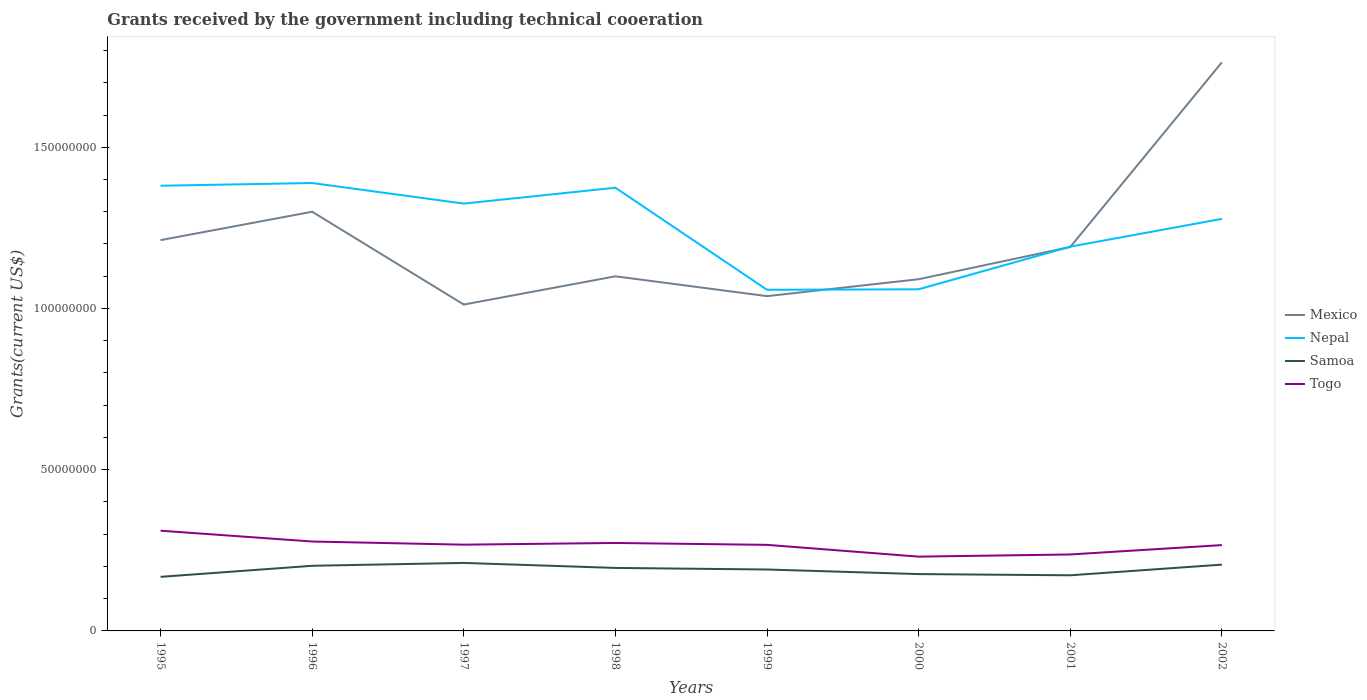How many different coloured lines are there?
Keep it short and to the point. 4. Does the line corresponding to Mexico intersect with the line corresponding to Samoa?
Keep it short and to the point. No. Across all years, what is the maximum total grants received by the government in Mexico?
Make the answer very short. 1.01e+08. In which year was the total grants received by the government in Togo maximum?
Your answer should be very brief. 2000. What is the total total grants received by the government in Togo in the graph?
Provide a succinct answer. -3.58e+06. What is the difference between the highest and the second highest total grants received by the government in Togo?
Give a very brief answer. 8.04e+06. What is the difference between the highest and the lowest total grants received by the government in Nepal?
Offer a terse response. 5. Is the total grants received by the government in Togo strictly greater than the total grants received by the government in Samoa over the years?
Keep it short and to the point. No. How many lines are there?
Keep it short and to the point. 4. How many years are there in the graph?
Offer a terse response. 8. Does the graph contain grids?
Keep it short and to the point. No. How many legend labels are there?
Offer a very short reply. 4. How are the legend labels stacked?
Ensure brevity in your answer.  Vertical. What is the title of the graph?
Provide a succinct answer. Grants received by the government including technical cooeration. Does "Japan" appear as one of the legend labels in the graph?
Your answer should be compact. No. What is the label or title of the X-axis?
Your answer should be compact. Years. What is the label or title of the Y-axis?
Give a very brief answer. Grants(current US$). What is the Grants(current US$) of Mexico in 1995?
Ensure brevity in your answer.  1.21e+08. What is the Grants(current US$) in Nepal in 1995?
Ensure brevity in your answer.  1.38e+08. What is the Grants(current US$) in Samoa in 1995?
Offer a very short reply. 1.68e+07. What is the Grants(current US$) of Togo in 1995?
Provide a short and direct response. 3.11e+07. What is the Grants(current US$) of Mexico in 1996?
Provide a succinct answer. 1.30e+08. What is the Grants(current US$) of Nepal in 1996?
Offer a terse response. 1.39e+08. What is the Grants(current US$) of Samoa in 1996?
Provide a short and direct response. 2.02e+07. What is the Grants(current US$) in Togo in 1996?
Keep it short and to the point. 2.77e+07. What is the Grants(current US$) of Mexico in 1997?
Your response must be concise. 1.01e+08. What is the Grants(current US$) in Nepal in 1997?
Offer a terse response. 1.33e+08. What is the Grants(current US$) of Samoa in 1997?
Keep it short and to the point. 2.11e+07. What is the Grants(current US$) in Togo in 1997?
Provide a succinct answer. 2.68e+07. What is the Grants(current US$) in Mexico in 1998?
Make the answer very short. 1.10e+08. What is the Grants(current US$) in Nepal in 1998?
Offer a terse response. 1.37e+08. What is the Grants(current US$) of Samoa in 1998?
Provide a short and direct response. 1.95e+07. What is the Grants(current US$) in Togo in 1998?
Your answer should be very brief. 2.73e+07. What is the Grants(current US$) in Mexico in 1999?
Ensure brevity in your answer.  1.04e+08. What is the Grants(current US$) of Nepal in 1999?
Offer a very short reply. 1.06e+08. What is the Grants(current US$) of Samoa in 1999?
Offer a terse response. 1.90e+07. What is the Grants(current US$) in Togo in 1999?
Your response must be concise. 2.67e+07. What is the Grants(current US$) in Mexico in 2000?
Ensure brevity in your answer.  1.09e+08. What is the Grants(current US$) in Nepal in 2000?
Offer a very short reply. 1.06e+08. What is the Grants(current US$) of Samoa in 2000?
Your answer should be compact. 1.76e+07. What is the Grants(current US$) of Togo in 2000?
Offer a terse response. 2.30e+07. What is the Grants(current US$) of Mexico in 2001?
Keep it short and to the point. 1.19e+08. What is the Grants(current US$) in Nepal in 2001?
Give a very brief answer. 1.19e+08. What is the Grants(current US$) of Samoa in 2001?
Offer a very short reply. 1.72e+07. What is the Grants(current US$) of Togo in 2001?
Offer a terse response. 2.37e+07. What is the Grants(current US$) of Mexico in 2002?
Offer a terse response. 1.76e+08. What is the Grants(current US$) of Nepal in 2002?
Offer a terse response. 1.28e+08. What is the Grants(current US$) in Samoa in 2002?
Offer a very short reply. 2.06e+07. What is the Grants(current US$) in Togo in 2002?
Your response must be concise. 2.66e+07. Across all years, what is the maximum Grants(current US$) in Mexico?
Give a very brief answer. 1.76e+08. Across all years, what is the maximum Grants(current US$) in Nepal?
Give a very brief answer. 1.39e+08. Across all years, what is the maximum Grants(current US$) of Samoa?
Keep it short and to the point. 2.11e+07. Across all years, what is the maximum Grants(current US$) of Togo?
Your response must be concise. 3.11e+07. Across all years, what is the minimum Grants(current US$) of Mexico?
Provide a succinct answer. 1.01e+08. Across all years, what is the minimum Grants(current US$) in Nepal?
Offer a terse response. 1.06e+08. Across all years, what is the minimum Grants(current US$) in Samoa?
Offer a very short reply. 1.68e+07. Across all years, what is the minimum Grants(current US$) of Togo?
Provide a succinct answer. 2.30e+07. What is the total Grants(current US$) of Mexico in the graph?
Give a very brief answer. 9.71e+08. What is the total Grants(current US$) in Nepal in the graph?
Make the answer very short. 1.01e+09. What is the total Grants(current US$) of Samoa in the graph?
Your answer should be very brief. 1.52e+08. What is the total Grants(current US$) of Togo in the graph?
Your answer should be compact. 2.13e+08. What is the difference between the Grants(current US$) in Mexico in 1995 and that in 1996?
Your answer should be compact. -8.80e+06. What is the difference between the Grants(current US$) in Nepal in 1995 and that in 1996?
Make the answer very short. -8.40e+05. What is the difference between the Grants(current US$) in Samoa in 1995 and that in 1996?
Ensure brevity in your answer.  -3.43e+06. What is the difference between the Grants(current US$) in Togo in 1995 and that in 1996?
Offer a terse response. 3.35e+06. What is the difference between the Grants(current US$) of Mexico in 1995 and that in 1997?
Give a very brief answer. 2.00e+07. What is the difference between the Grants(current US$) in Nepal in 1995 and that in 1997?
Give a very brief answer. 5.54e+06. What is the difference between the Grants(current US$) of Samoa in 1995 and that in 1997?
Your answer should be very brief. -4.32e+06. What is the difference between the Grants(current US$) in Togo in 1995 and that in 1997?
Provide a succinct answer. 4.33e+06. What is the difference between the Grants(current US$) in Mexico in 1995 and that in 1998?
Keep it short and to the point. 1.12e+07. What is the difference between the Grants(current US$) of Nepal in 1995 and that in 1998?
Offer a terse response. 6.20e+05. What is the difference between the Grants(current US$) in Samoa in 1995 and that in 1998?
Provide a short and direct response. -2.77e+06. What is the difference between the Grants(current US$) of Togo in 1995 and that in 1998?
Your answer should be very brief. 3.80e+06. What is the difference between the Grants(current US$) of Mexico in 1995 and that in 1999?
Make the answer very short. 1.74e+07. What is the difference between the Grants(current US$) of Nepal in 1995 and that in 1999?
Your answer should be compact. 3.23e+07. What is the difference between the Grants(current US$) of Samoa in 1995 and that in 1999?
Ensure brevity in your answer.  -2.28e+06. What is the difference between the Grants(current US$) of Togo in 1995 and that in 1999?
Provide a succinct answer. 4.39e+06. What is the difference between the Grants(current US$) of Mexico in 1995 and that in 2000?
Provide a succinct answer. 1.21e+07. What is the difference between the Grants(current US$) of Nepal in 1995 and that in 2000?
Your answer should be very brief. 3.21e+07. What is the difference between the Grants(current US$) in Samoa in 1995 and that in 2000?
Keep it short and to the point. -8.60e+05. What is the difference between the Grants(current US$) in Togo in 1995 and that in 2000?
Your answer should be very brief. 8.04e+06. What is the difference between the Grants(current US$) in Mexico in 1995 and that in 2001?
Give a very brief answer. 2.13e+06. What is the difference between the Grants(current US$) of Nepal in 1995 and that in 2001?
Offer a very short reply. 1.89e+07. What is the difference between the Grants(current US$) in Samoa in 1995 and that in 2001?
Your answer should be very brief. -4.80e+05. What is the difference between the Grants(current US$) in Togo in 1995 and that in 2001?
Your answer should be very brief. 7.37e+06. What is the difference between the Grants(current US$) in Mexico in 1995 and that in 2002?
Provide a succinct answer. -5.52e+07. What is the difference between the Grants(current US$) in Nepal in 1995 and that in 2002?
Offer a very short reply. 1.03e+07. What is the difference between the Grants(current US$) in Samoa in 1995 and that in 2002?
Your response must be concise. -3.79e+06. What is the difference between the Grants(current US$) in Togo in 1995 and that in 2002?
Your response must be concise. 4.46e+06. What is the difference between the Grants(current US$) in Mexico in 1996 and that in 1997?
Your response must be concise. 2.88e+07. What is the difference between the Grants(current US$) in Nepal in 1996 and that in 1997?
Make the answer very short. 6.38e+06. What is the difference between the Grants(current US$) in Samoa in 1996 and that in 1997?
Make the answer very short. -8.90e+05. What is the difference between the Grants(current US$) of Togo in 1996 and that in 1997?
Make the answer very short. 9.80e+05. What is the difference between the Grants(current US$) in Mexico in 1996 and that in 1998?
Ensure brevity in your answer.  2.00e+07. What is the difference between the Grants(current US$) of Nepal in 1996 and that in 1998?
Provide a short and direct response. 1.46e+06. What is the difference between the Grants(current US$) of Mexico in 1996 and that in 1999?
Ensure brevity in your answer.  2.62e+07. What is the difference between the Grants(current US$) of Nepal in 1996 and that in 1999?
Provide a succinct answer. 3.31e+07. What is the difference between the Grants(current US$) of Samoa in 1996 and that in 1999?
Your answer should be very brief. 1.15e+06. What is the difference between the Grants(current US$) in Togo in 1996 and that in 1999?
Provide a succinct answer. 1.04e+06. What is the difference between the Grants(current US$) in Mexico in 1996 and that in 2000?
Your answer should be compact. 2.09e+07. What is the difference between the Grants(current US$) in Nepal in 1996 and that in 2000?
Provide a succinct answer. 3.30e+07. What is the difference between the Grants(current US$) in Samoa in 1996 and that in 2000?
Give a very brief answer. 2.57e+06. What is the difference between the Grants(current US$) in Togo in 1996 and that in 2000?
Provide a short and direct response. 4.69e+06. What is the difference between the Grants(current US$) of Mexico in 1996 and that in 2001?
Provide a short and direct response. 1.09e+07. What is the difference between the Grants(current US$) in Nepal in 1996 and that in 2001?
Offer a very short reply. 1.97e+07. What is the difference between the Grants(current US$) of Samoa in 1996 and that in 2001?
Offer a terse response. 2.95e+06. What is the difference between the Grants(current US$) in Togo in 1996 and that in 2001?
Provide a short and direct response. 4.02e+06. What is the difference between the Grants(current US$) in Mexico in 1996 and that in 2002?
Your answer should be compact. -4.64e+07. What is the difference between the Grants(current US$) of Nepal in 1996 and that in 2002?
Your answer should be very brief. 1.11e+07. What is the difference between the Grants(current US$) of Samoa in 1996 and that in 2002?
Ensure brevity in your answer.  -3.60e+05. What is the difference between the Grants(current US$) of Togo in 1996 and that in 2002?
Offer a terse response. 1.11e+06. What is the difference between the Grants(current US$) of Mexico in 1997 and that in 1998?
Offer a terse response. -8.76e+06. What is the difference between the Grants(current US$) in Nepal in 1997 and that in 1998?
Ensure brevity in your answer.  -4.92e+06. What is the difference between the Grants(current US$) in Samoa in 1997 and that in 1998?
Make the answer very short. 1.55e+06. What is the difference between the Grants(current US$) of Togo in 1997 and that in 1998?
Ensure brevity in your answer.  -5.30e+05. What is the difference between the Grants(current US$) of Mexico in 1997 and that in 1999?
Provide a short and direct response. -2.61e+06. What is the difference between the Grants(current US$) of Nepal in 1997 and that in 1999?
Ensure brevity in your answer.  2.67e+07. What is the difference between the Grants(current US$) in Samoa in 1997 and that in 1999?
Offer a very short reply. 2.04e+06. What is the difference between the Grants(current US$) of Togo in 1997 and that in 1999?
Offer a very short reply. 6.00e+04. What is the difference between the Grants(current US$) of Mexico in 1997 and that in 2000?
Your response must be concise. -7.86e+06. What is the difference between the Grants(current US$) of Nepal in 1997 and that in 2000?
Make the answer very short. 2.66e+07. What is the difference between the Grants(current US$) in Samoa in 1997 and that in 2000?
Your response must be concise. 3.46e+06. What is the difference between the Grants(current US$) in Togo in 1997 and that in 2000?
Your answer should be very brief. 3.71e+06. What is the difference between the Grants(current US$) in Mexico in 1997 and that in 2001?
Your answer should be very brief. -1.78e+07. What is the difference between the Grants(current US$) in Nepal in 1997 and that in 2001?
Your answer should be compact. 1.34e+07. What is the difference between the Grants(current US$) of Samoa in 1997 and that in 2001?
Provide a short and direct response. 3.84e+06. What is the difference between the Grants(current US$) of Togo in 1997 and that in 2001?
Provide a short and direct response. 3.04e+06. What is the difference between the Grants(current US$) of Mexico in 1997 and that in 2002?
Offer a terse response. -7.51e+07. What is the difference between the Grants(current US$) in Nepal in 1997 and that in 2002?
Keep it short and to the point. 4.74e+06. What is the difference between the Grants(current US$) of Samoa in 1997 and that in 2002?
Your answer should be compact. 5.30e+05. What is the difference between the Grants(current US$) of Togo in 1997 and that in 2002?
Offer a very short reply. 1.30e+05. What is the difference between the Grants(current US$) in Mexico in 1998 and that in 1999?
Your answer should be compact. 6.15e+06. What is the difference between the Grants(current US$) in Nepal in 1998 and that in 1999?
Your answer should be compact. 3.16e+07. What is the difference between the Grants(current US$) of Samoa in 1998 and that in 1999?
Make the answer very short. 4.90e+05. What is the difference between the Grants(current US$) of Togo in 1998 and that in 1999?
Give a very brief answer. 5.90e+05. What is the difference between the Grants(current US$) of Mexico in 1998 and that in 2000?
Offer a very short reply. 9.00e+05. What is the difference between the Grants(current US$) in Nepal in 1998 and that in 2000?
Offer a very short reply. 3.15e+07. What is the difference between the Grants(current US$) of Samoa in 1998 and that in 2000?
Your answer should be compact. 1.91e+06. What is the difference between the Grants(current US$) of Togo in 1998 and that in 2000?
Give a very brief answer. 4.24e+06. What is the difference between the Grants(current US$) in Mexico in 1998 and that in 2001?
Provide a succinct answer. -9.09e+06. What is the difference between the Grants(current US$) of Nepal in 1998 and that in 2001?
Provide a short and direct response. 1.83e+07. What is the difference between the Grants(current US$) of Samoa in 1998 and that in 2001?
Your answer should be compact. 2.29e+06. What is the difference between the Grants(current US$) in Togo in 1998 and that in 2001?
Keep it short and to the point. 3.57e+06. What is the difference between the Grants(current US$) of Mexico in 1998 and that in 2002?
Provide a short and direct response. -6.64e+07. What is the difference between the Grants(current US$) of Nepal in 1998 and that in 2002?
Ensure brevity in your answer.  9.66e+06. What is the difference between the Grants(current US$) of Samoa in 1998 and that in 2002?
Your response must be concise. -1.02e+06. What is the difference between the Grants(current US$) of Togo in 1998 and that in 2002?
Provide a short and direct response. 6.60e+05. What is the difference between the Grants(current US$) of Mexico in 1999 and that in 2000?
Offer a terse response. -5.25e+06. What is the difference between the Grants(current US$) of Samoa in 1999 and that in 2000?
Ensure brevity in your answer.  1.42e+06. What is the difference between the Grants(current US$) of Togo in 1999 and that in 2000?
Provide a succinct answer. 3.65e+06. What is the difference between the Grants(current US$) in Mexico in 1999 and that in 2001?
Offer a terse response. -1.52e+07. What is the difference between the Grants(current US$) of Nepal in 1999 and that in 2001?
Provide a short and direct response. -1.34e+07. What is the difference between the Grants(current US$) in Samoa in 1999 and that in 2001?
Keep it short and to the point. 1.80e+06. What is the difference between the Grants(current US$) of Togo in 1999 and that in 2001?
Offer a terse response. 2.98e+06. What is the difference between the Grants(current US$) of Mexico in 1999 and that in 2002?
Your response must be concise. -7.25e+07. What is the difference between the Grants(current US$) in Nepal in 1999 and that in 2002?
Provide a short and direct response. -2.20e+07. What is the difference between the Grants(current US$) of Samoa in 1999 and that in 2002?
Your answer should be compact. -1.51e+06. What is the difference between the Grants(current US$) in Togo in 1999 and that in 2002?
Make the answer very short. 7.00e+04. What is the difference between the Grants(current US$) in Mexico in 2000 and that in 2001?
Your answer should be compact. -9.99e+06. What is the difference between the Grants(current US$) of Nepal in 2000 and that in 2001?
Provide a short and direct response. -1.32e+07. What is the difference between the Grants(current US$) in Samoa in 2000 and that in 2001?
Provide a short and direct response. 3.80e+05. What is the difference between the Grants(current US$) in Togo in 2000 and that in 2001?
Your answer should be very brief. -6.70e+05. What is the difference between the Grants(current US$) of Mexico in 2000 and that in 2002?
Give a very brief answer. -6.73e+07. What is the difference between the Grants(current US$) in Nepal in 2000 and that in 2002?
Your answer should be very brief. -2.18e+07. What is the difference between the Grants(current US$) of Samoa in 2000 and that in 2002?
Offer a terse response. -2.93e+06. What is the difference between the Grants(current US$) of Togo in 2000 and that in 2002?
Keep it short and to the point. -3.58e+06. What is the difference between the Grants(current US$) of Mexico in 2001 and that in 2002?
Ensure brevity in your answer.  -5.73e+07. What is the difference between the Grants(current US$) in Nepal in 2001 and that in 2002?
Keep it short and to the point. -8.62e+06. What is the difference between the Grants(current US$) of Samoa in 2001 and that in 2002?
Your answer should be compact. -3.31e+06. What is the difference between the Grants(current US$) of Togo in 2001 and that in 2002?
Your response must be concise. -2.91e+06. What is the difference between the Grants(current US$) of Mexico in 1995 and the Grants(current US$) of Nepal in 1996?
Offer a terse response. -1.77e+07. What is the difference between the Grants(current US$) in Mexico in 1995 and the Grants(current US$) in Samoa in 1996?
Your answer should be compact. 1.01e+08. What is the difference between the Grants(current US$) of Mexico in 1995 and the Grants(current US$) of Togo in 1996?
Provide a short and direct response. 9.35e+07. What is the difference between the Grants(current US$) of Nepal in 1995 and the Grants(current US$) of Samoa in 1996?
Your response must be concise. 1.18e+08. What is the difference between the Grants(current US$) of Nepal in 1995 and the Grants(current US$) of Togo in 1996?
Provide a succinct answer. 1.10e+08. What is the difference between the Grants(current US$) in Samoa in 1995 and the Grants(current US$) in Togo in 1996?
Give a very brief answer. -1.10e+07. What is the difference between the Grants(current US$) of Mexico in 1995 and the Grants(current US$) of Nepal in 1997?
Provide a short and direct response. -1.13e+07. What is the difference between the Grants(current US$) of Mexico in 1995 and the Grants(current US$) of Samoa in 1997?
Your answer should be very brief. 1.00e+08. What is the difference between the Grants(current US$) in Mexico in 1995 and the Grants(current US$) in Togo in 1997?
Your answer should be very brief. 9.44e+07. What is the difference between the Grants(current US$) in Nepal in 1995 and the Grants(current US$) in Samoa in 1997?
Give a very brief answer. 1.17e+08. What is the difference between the Grants(current US$) in Nepal in 1995 and the Grants(current US$) in Togo in 1997?
Make the answer very short. 1.11e+08. What is the difference between the Grants(current US$) in Samoa in 1995 and the Grants(current US$) in Togo in 1997?
Provide a succinct answer. -9.98e+06. What is the difference between the Grants(current US$) of Mexico in 1995 and the Grants(current US$) of Nepal in 1998?
Give a very brief answer. -1.62e+07. What is the difference between the Grants(current US$) in Mexico in 1995 and the Grants(current US$) in Samoa in 1998?
Make the answer very short. 1.02e+08. What is the difference between the Grants(current US$) of Mexico in 1995 and the Grants(current US$) of Togo in 1998?
Your answer should be compact. 9.39e+07. What is the difference between the Grants(current US$) of Nepal in 1995 and the Grants(current US$) of Samoa in 1998?
Offer a very short reply. 1.19e+08. What is the difference between the Grants(current US$) in Nepal in 1995 and the Grants(current US$) in Togo in 1998?
Your answer should be compact. 1.11e+08. What is the difference between the Grants(current US$) in Samoa in 1995 and the Grants(current US$) in Togo in 1998?
Offer a very short reply. -1.05e+07. What is the difference between the Grants(current US$) of Mexico in 1995 and the Grants(current US$) of Nepal in 1999?
Make the answer very short. 1.54e+07. What is the difference between the Grants(current US$) of Mexico in 1995 and the Grants(current US$) of Samoa in 1999?
Your answer should be compact. 1.02e+08. What is the difference between the Grants(current US$) in Mexico in 1995 and the Grants(current US$) in Togo in 1999?
Provide a short and direct response. 9.45e+07. What is the difference between the Grants(current US$) in Nepal in 1995 and the Grants(current US$) in Samoa in 1999?
Your answer should be compact. 1.19e+08. What is the difference between the Grants(current US$) of Nepal in 1995 and the Grants(current US$) of Togo in 1999?
Your answer should be compact. 1.11e+08. What is the difference between the Grants(current US$) of Samoa in 1995 and the Grants(current US$) of Togo in 1999?
Provide a short and direct response. -9.92e+06. What is the difference between the Grants(current US$) of Mexico in 1995 and the Grants(current US$) of Nepal in 2000?
Your response must be concise. 1.52e+07. What is the difference between the Grants(current US$) of Mexico in 1995 and the Grants(current US$) of Samoa in 2000?
Your response must be concise. 1.04e+08. What is the difference between the Grants(current US$) in Mexico in 1995 and the Grants(current US$) in Togo in 2000?
Ensure brevity in your answer.  9.82e+07. What is the difference between the Grants(current US$) of Nepal in 1995 and the Grants(current US$) of Samoa in 2000?
Provide a short and direct response. 1.20e+08. What is the difference between the Grants(current US$) of Nepal in 1995 and the Grants(current US$) of Togo in 2000?
Ensure brevity in your answer.  1.15e+08. What is the difference between the Grants(current US$) in Samoa in 1995 and the Grants(current US$) in Togo in 2000?
Ensure brevity in your answer.  -6.27e+06. What is the difference between the Grants(current US$) of Mexico in 1995 and the Grants(current US$) of Nepal in 2001?
Ensure brevity in your answer.  2.03e+06. What is the difference between the Grants(current US$) in Mexico in 1995 and the Grants(current US$) in Samoa in 2001?
Offer a very short reply. 1.04e+08. What is the difference between the Grants(current US$) of Mexico in 1995 and the Grants(current US$) of Togo in 2001?
Keep it short and to the point. 9.75e+07. What is the difference between the Grants(current US$) of Nepal in 1995 and the Grants(current US$) of Samoa in 2001?
Your response must be concise. 1.21e+08. What is the difference between the Grants(current US$) in Nepal in 1995 and the Grants(current US$) in Togo in 2001?
Keep it short and to the point. 1.14e+08. What is the difference between the Grants(current US$) in Samoa in 1995 and the Grants(current US$) in Togo in 2001?
Provide a short and direct response. -6.94e+06. What is the difference between the Grants(current US$) in Mexico in 1995 and the Grants(current US$) in Nepal in 2002?
Ensure brevity in your answer.  -6.59e+06. What is the difference between the Grants(current US$) of Mexico in 1995 and the Grants(current US$) of Samoa in 2002?
Offer a terse response. 1.01e+08. What is the difference between the Grants(current US$) in Mexico in 1995 and the Grants(current US$) in Togo in 2002?
Your answer should be very brief. 9.46e+07. What is the difference between the Grants(current US$) of Nepal in 1995 and the Grants(current US$) of Samoa in 2002?
Your answer should be compact. 1.18e+08. What is the difference between the Grants(current US$) of Nepal in 1995 and the Grants(current US$) of Togo in 2002?
Ensure brevity in your answer.  1.11e+08. What is the difference between the Grants(current US$) of Samoa in 1995 and the Grants(current US$) of Togo in 2002?
Your answer should be very brief. -9.85e+06. What is the difference between the Grants(current US$) of Mexico in 1996 and the Grants(current US$) of Nepal in 1997?
Provide a succinct answer. -2.53e+06. What is the difference between the Grants(current US$) of Mexico in 1996 and the Grants(current US$) of Samoa in 1997?
Offer a very short reply. 1.09e+08. What is the difference between the Grants(current US$) in Mexico in 1996 and the Grants(current US$) in Togo in 1997?
Provide a succinct answer. 1.03e+08. What is the difference between the Grants(current US$) in Nepal in 1996 and the Grants(current US$) in Samoa in 1997?
Offer a very short reply. 1.18e+08. What is the difference between the Grants(current US$) in Nepal in 1996 and the Grants(current US$) in Togo in 1997?
Your answer should be very brief. 1.12e+08. What is the difference between the Grants(current US$) of Samoa in 1996 and the Grants(current US$) of Togo in 1997?
Provide a short and direct response. -6.55e+06. What is the difference between the Grants(current US$) of Mexico in 1996 and the Grants(current US$) of Nepal in 1998?
Provide a short and direct response. -7.45e+06. What is the difference between the Grants(current US$) of Mexico in 1996 and the Grants(current US$) of Samoa in 1998?
Your response must be concise. 1.10e+08. What is the difference between the Grants(current US$) in Mexico in 1996 and the Grants(current US$) in Togo in 1998?
Provide a short and direct response. 1.03e+08. What is the difference between the Grants(current US$) of Nepal in 1996 and the Grants(current US$) of Samoa in 1998?
Provide a short and direct response. 1.19e+08. What is the difference between the Grants(current US$) in Nepal in 1996 and the Grants(current US$) in Togo in 1998?
Offer a very short reply. 1.12e+08. What is the difference between the Grants(current US$) of Samoa in 1996 and the Grants(current US$) of Togo in 1998?
Your answer should be compact. -7.08e+06. What is the difference between the Grants(current US$) in Mexico in 1996 and the Grants(current US$) in Nepal in 1999?
Keep it short and to the point. 2.42e+07. What is the difference between the Grants(current US$) of Mexico in 1996 and the Grants(current US$) of Samoa in 1999?
Make the answer very short. 1.11e+08. What is the difference between the Grants(current US$) of Mexico in 1996 and the Grants(current US$) of Togo in 1999?
Give a very brief answer. 1.03e+08. What is the difference between the Grants(current US$) of Nepal in 1996 and the Grants(current US$) of Samoa in 1999?
Give a very brief answer. 1.20e+08. What is the difference between the Grants(current US$) in Nepal in 1996 and the Grants(current US$) in Togo in 1999?
Ensure brevity in your answer.  1.12e+08. What is the difference between the Grants(current US$) of Samoa in 1996 and the Grants(current US$) of Togo in 1999?
Your response must be concise. -6.49e+06. What is the difference between the Grants(current US$) of Mexico in 1996 and the Grants(current US$) of Nepal in 2000?
Give a very brief answer. 2.40e+07. What is the difference between the Grants(current US$) in Mexico in 1996 and the Grants(current US$) in Samoa in 2000?
Keep it short and to the point. 1.12e+08. What is the difference between the Grants(current US$) in Mexico in 1996 and the Grants(current US$) in Togo in 2000?
Your answer should be very brief. 1.07e+08. What is the difference between the Grants(current US$) in Nepal in 1996 and the Grants(current US$) in Samoa in 2000?
Keep it short and to the point. 1.21e+08. What is the difference between the Grants(current US$) in Nepal in 1996 and the Grants(current US$) in Togo in 2000?
Your response must be concise. 1.16e+08. What is the difference between the Grants(current US$) of Samoa in 1996 and the Grants(current US$) of Togo in 2000?
Offer a very short reply. -2.84e+06. What is the difference between the Grants(current US$) in Mexico in 1996 and the Grants(current US$) in Nepal in 2001?
Keep it short and to the point. 1.08e+07. What is the difference between the Grants(current US$) in Mexico in 1996 and the Grants(current US$) in Samoa in 2001?
Your response must be concise. 1.13e+08. What is the difference between the Grants(current US$) of Mexico in 1996 and the Grants(current US$) of Togo in 2001?
Provide a succinct answer. 1.06e+08. What is the difference between the Grants(current US$) of Nepal in 1996 and the Grants(current US$) of Samoa in 2001?
Give a very brief answer. 1.22e+08. What is the difference between the Grants(current US$) of Nepal in 1996 and the Grants(current US$) of Togo in 2001?
Offer a terse response. 1.15e+08. What is the difference between the Grants(current US$) in Samoa in 1996 and the Grants(current US$) in Togo in 2001?
Ensure brevity in your answer.  -3.51e+06. What is the difference between the Grants(current US$) in Mexico in 1996 and the Grants(current US$) in Nepal in 2002?
Provide a short and direct response. 2.21e+06. What is the difference between the Grants(current US$) in Mexico in 1996 and the Grants(current US$) in Samoa in 2002?
Give a very brief answer. 1.09e+08. What is the difference between the Grants(current US$) of Mexico in 1996 and the Grants(current US$) of Togo in 2002?
Your response must be concise. 1.03e+08. What is the difference between the Grants(current US$) in Nepal in 1996 and the Grants(current US$) in Samoa in 2002?
Give a very brief answer. 1.18e+08. What is the difference between the Grants(current US$) in Nepal in 1996 and the Grants(current US$) in Togo in 2002?
Ensure brevity in your answer.  1.12e+08. What is the difference between the Grants(current US$) of Samoa in 1996 and the Grants(current US$) of Togo in 2002?
Keep it short and to the point. -6.42e+06. What is the difference between the Grants(current US$) in Mexico in 1997 and the Grants(current US$) in Nepal in 1998?
Ensure brevity in your answer.  -3.62e+07. What is the difference between the Grants(current US$) in Mexico in 1997 and the Grants(current US$) in Samoa in 1998?
Provide a succinct answer. 8.17e+07. What is the difference between the Grants(current US$) in Mexico in 1997 and the Grants(current US$) in Togo in 1998?
Your answer should be compact. 7.39e+07. What is the difference between the Grants(current US$) in Nepal in 1997 and the Grants(current US$) in Samoa in 1998?
Offer a very short reply. 1.13e+08. What is the difference between the Grants(current US$) in Nepal in 1997 and the Grants(current US$) in Togo in 1998?
Ensure brevity in your answer.  1.05e+08. What is the difference between the Grants(current US$) of Samoa in 1997 and the Grants(current US$) of Togo in 1998?
Give a very brief answer. -6.19e+06. What is the difference between the Grants(current US$) of Mexico in 1997 and the Grants(current US$) of Nepal in 1999?
Provide a short and direct response. -4.58e+06. What is the difference between the Grants(current US$) of Mexico in 1997 and the Grants(current US$) of Samoa in 1999?
Offer a very short reply. 8.22e+07. What is the difference between the Grants(current US$) in Mexico in 1997 and the Grants(current US$) in Togo in 1999?
Offer a terse response. 7.45e+07. What is the difference between the Grants(current US$) in Nepal in 1997 and the Grants(current US$) in Samoa in 1999?
Keep it short and to the point. 1.13e+08. What is the difference between the Grants(current US$) in Nepal in 1997 and the Grants(current US$) in Togo in 1999?
Make the answer very short. 1.06e+08. What is the difference between the Grants(current US$) in Samoa in 1997 and the Grants(current US$) in Togo in 1999?
Make the answer very short. -5.60e+06. What is the difference between the Grants(current US$) in Mexico in 1997 and the Grants(current US$) in Nepal in 2000?
Give a very brief answer. -4.73e+06. What is the difference between the Grants(current US$) of Mexico in 1997 and the Grants(current US$) of Samoa in 2000?
Give a very brief answer. 8.36e+07. What is the difference between the Grants(current US$) in Mexico in 1997 and the Grants(current US$) in Togo in 2000?
Ensure brevity in your answer.  7.82e+07. What is the difference between the Grants(current US$) in Nepal in 1997 and the Grants(current US$) in Samoa in 2000?
Offer a terse response. 1.15e+08. What is the difference between the Grants(current US$) in Nepal in 1997 and the Grants(current US$) in Togo in 2000?
Make the answer very short. 1.09e+08. What is the difference between the Grants(current US$) in Samoa in 1997 and the Grants(current US$) in Togo in 2000?
Provide a succinct answer. -1.95e+06. What is the difference between the Grants(current US$) of Mexico in 1997 and the Grants(current US$) of Nepal in 2001?
Ensure brevity in your answer.  -1.80e+07. What is the difference between the Grants(current US$) in Mexico in 1997 and the Grants(current US$) in Samoa in 2001?
Keep it short and to the point. 8.40e+07. What is the difference between the Grants(current US$) of Mexico in 1997 and the Grants(current US$) of Togo in 2001?
Offer a very short reply. 7.75e+07. What is the difference between the Grants(current US$) of Nepal in 1997 and the Grants(current US$) of Samoa in 2001?
Provide a short and direct response. 1.15e+08. What is the difference between the Grants(current US$) of Nepal in 1997 and the Grants(current US$) of Togo in 2001?
Your answer should be compact. 1.09e+08. What is the difference between the Grants(current US$) in Samoa in 1997 and the Grants(current US$) in Togo in 2001?
Keep it short and to the point. -2.62e+06. What is the difference between the Grants(current US$) in Mexico in 1997 and the Grants(current US$) in Nepal in 2002?
Your response must be concise. -2.66e+07. What is the difference between the Grants(current US$) of Mexico in 1997 and the Grants(current US$) of Samoa in 2002?
Ensure brevity in your answer.  8.07e+07. What is the difference between the Grants(current US$) in Mexico in 1997 and the Grants(current US$) in Togo in 2002?
Your answer should be compact. 7.46e+07. What is the difference between the Grants(current US$) of Nepal in 1997 and the Grants(current US$) of Samoa in 2002?
Your response must be concise. 1.12e+08. What is the difference between the Grants(current US$) of Nepal in 1997 and the Grants(current US$) of Togo in 2002?
Your answer should be compact. 1.06e+08. What is the difference between the Grants(current US$) of Samoa in 1997 and the Grants(current US$) of Togo in 2002?
Give a very brief answer. -5.53e+06. What is the difference between the Grants(current US$) in Mexico in 1998 and the Grants(current US$) in Nepal in 1999?
Your answer should be very brief. 4.18e+06. What is the difference between the Grants(current US$) of Mexico in 1998 and the Grants(current US$) of Samoa in 1999?
Offer a very short reply. 9.09e+07. What is the difference between the Grants(current US$) of Mexico in 1998 and the Grants(current US$) of Togo in 1999?
Offer a very short reply. 8.33e+07. What is the difference between the Grants(current US$) in Nepal in 1998 and the Grants(current US$) in Samoa in 1999?
Your answer should be very brief. 1.18e+08. What is the difference between the Grants(current US$) in Nepal in 1998 and the Grants(current US$) in Togo in 1999?
Provide a short and direct response. 1.11e+08. What is the difference between the Grants(current US$) in Samoa in 1998 and the Grants(current US$) in Togo in 1999?
Give a very brief answer. -7.15e+06. What is the difference between the Grants(current US$) in Mexico in 1998 and the Grants(current US$) in Nepal in 2000?
Provide a succinct answer. 4.03e+06. What is the difference between the Grants(current US$) in Mexico in 1998 and the Grants(current US$) in Samoa in 2000?
Provide a short and direct response. 9.24e+07. What is the difference between the Grants(current US$) in Mexico in 1998 and the Grants(current US$) in Togo in 2000?
Provide a succinct answer. 8.69e+07. What is the difference between the Grants(current US$) of Nepal in 1998 and the Grants(current US$) of Samoa in 2000?
Give a very brief answer. 1.20e+08. What is the difference between the Grants(current US$) in Nepal in 1998 and the Grants(current US$) in Togo in 2000?
Your answer should be very brief. 1.14e+08. What is the difference between the Grants(current US$) of Samoa in 1998 and the Grants(current US$) of Togo in 2000?
Provide a short and direct response. -3.50e+06. What is the difference between the Grants(current US$) of Mexico in 1998 and the Grants(current US$) of Nepal in 2001?
Make the answer very short. -9.19e+06. What is the difference between the Grants(current US$) of Mexico in 1998 and the Grants(current US$) of Samoa in 2001?
Your answer should be compact. 9.27e+07. What is the difference between the Grants(current US$) in Mexico in 1998 and the Grants(current US$) in Togo in 2001?
Offer a terse response. 8.63e+07. What is the difference between the Grants(current US$) in Nepal in 1998 and the Grants(current US$) in Samoa in 2001?
Offer a very short reply. 1.20e+08. What is the difference between the Grants(current US$) of Nepal in 1998 and the Grants(current US$) of Togo in 2001?
Offer a terse response. 1.14e+08. What is the difference between the Grants(current US$) in Samoa in 1998 and the Grants(current US$) in Togo in 2001?
Provide a short and direct response. -4.17e+06. What is the difference between the Grants(current US$) in Mexico in 1998 and the Grants(current US$) in Nepal in 2002?
Your answer should be very brief. -1.78e+07. What is the difference between the Grants(current US$) of Mexico in 1998 and the Grants(current US$) of Samoa in 2002?
Offer a terse response. 8.94e+07. What is the difference between the Grants(current US$) in Mexico in 1998 and the Grants(current US$) in Togo in 2002?
Ensure brevity in your answer.  8.34e+07. What is the difference between the Grants(current US$) in Nepal in 1998 and the Grants(current US$) in Samoa in 2002?
Your answer should be compact. 1.17e+08. What is the difference between the Grants(current US$) of Nepal in 1998 and the Grants(current US$) of Togo in 2002?
Your answer should be compact. 1.11e+08. What is the difference between the Grants(current US$) in Samoa in 1998 and the Grants(current US$) in Togo in 2002?
Your response must be concise. -7.08e+06. What is the difference between the Grants(current US$) of Mexico in 1999 and the Grants(current US$) of Nepal in 2000?
Provide a short and direct response. -2.12e+06. What is the difference between the Grants(current US$) in Mexico in 1999 and the Grants(current US$) in Samoa in 2000?
Offer a very short reply. 8.62e+07. What is the difference between the Grants(current US$) in Mexico in 1999 and the Grants(current US$) in Togo in 2000?
Offer a terse response. 8.08e+07. What is the difference between the Grants(current US$) in Nepal in 1999 and the Grants(current US$) in Samoa in 2000?
Provide a short and direct response. 8.82e+07. What is the difference between the Grants(current US$) in Nepal in 1999 and the Grants(current US$) in Togo in 2000?
Your answer should be compact. 8.28e+07. What is the difference between the Grants(current US$) in Samoa in 1999 and the Grants(current US$) in Togo in 2000?
Provide a short and direct response. -3.99e+06. What is the difference between the Grants(current US$) in Mexico in 1999 and the Grants(current US$) in Nepal in 2001?
Provide a short and direct response. -1.53e+07. What is the difference between the Grants(current US$) in Mexico in 1999 and the Grants(current US$) in Samoa in 2001?
Provide a succinct answer. 8.66e+07. What is the difference between the Grants(current US$) of Mexico in 1999 and the Grants(current US$) of Togo in 2001?
Make the answer very short. 8.01e+07. What is the difference between the Grants(current US$) in Nepal in 1999 and the Grants(current US$) in Samoa in 2001?
Keep it short and to the point. 8.86e+07. What is the difference between the Grants(current US$) of Nepal in 1999 and the Grants(current US$) of Togo in 2001?
Give a very brief answer. 8.21e+07. What is the difference between the Grants(current US$) in Samoa in 1999 and the Grants(current US$) in Togo in 2001?
Give a very brief answer. -4.66e+06. What is the difference between the Grants(current US$) in Mexico in 1999 and the Grants(current US$) in Nepal in 2002?
Ensure brevity in your answer.  -2.40e+07. What is the difference between the Grants(current US$) in Mexico in 1999 and the Grants(current US$) in Samoa in 2002?
Keep it short and to the point. 8.33e+07. What is the difference between the Grants(current US$) of Mexico in 1999 and the Grants(current US$) of Togo in 2002?
Give a very brief answer. 7.72e+07. What is the difference between the Grants(current US$) in Nepal in 1999 and the Grants(current US$) in Samoa in 2002?
Provide a short and direct response. 8.52e+07. What is the difference between the Grants(current US$) in Nepal in 1999 and the Grants(current US$) in Togo in 2002?
Offer a terse response. 7.92e+07. What is the difference between the Grants(current US$) of Samoa in 1999 and the Grants(current US$) of Togo in 2002?
Your response must be concise. -7.57e+06. What is the difference between the Grants(current US$) in Mexico in 2000 and the Grants(current US$) in Nepal in 2001?
Give a very brief answer. -1.01e+07. What is the difference between the Grants(current US$) in Mexico in 2000 and the Grants(current US$) in Samoa in 2001?
Offer a very short reply. 9.18e+07. What is the difference between the Grants(current US$) in Mexico in 2000 and the Grants(current US$) in Togo in 2001?
Give a very brief answer. 8.54e+07. What is the difference between the Grants(current US$) in Nepal in 2000 and the Grants(current US$) in Samoa in 2001?
Keep it short and to the point. 8.87e+07. What is the difference between the Grants(current US$) of Nepal in 2000 and the Grants(current US$) of Togo in 2001?
Your response must be concise. 8.22e+07. What is the difference between the Grants(current US$) in Samoa in 2000 and the Grants(current US$) in Togo in 2001?
Make the answer very short. -6.08e+06. What is the difference between the Grants(current US$) in Mexico in 2000 and the Grants(current US$) in Nepal in 2002?
Offer a terse response. -1.87e+07. What is the difference between the Grants(current US$) of Mexico in 2000 and the Grants(current US$) of Samoa in 2002?
Your answer should be compact. 8.85e+07. What is the difference between the Grants(current US$) in Mexico in 2000 and the Grants(current US$) in Togo in 2002?
Ensure brevity in your answer.  8.25e+07. What is the difference between the Grants(current US$) in Nepal in 2000 and the Grants(current US$) in Samoa in 2002?
Ensure brevity in your answer.  8.54e+07. What is the difference between the Grants(current US$) in Nepal in 2000 and the Grants(current US$) in Togo in 2002?
Ensure brevity in your answer.  7.93e+07. What is the difference between the Grants(current US$) in Samoa in 2000 and the Grants(current US$) in Togo in 2002?
Make the answer very short. -8.99e+06. What is the difference between the Grants(current US$) of Mexico in 2001 and the Grants(current US$) of Nepal in 2002?
Offer a very short reply. -8.72e+06. What is the difference between the Grants(current US$) in Mexico in 2001 and the Grants(current US$) in Samoa in 2002?
Provide a short and direct response. 9.85e+07. What is the difference between the Grants(current US$) of Mexico in 2001 and the Grants(current US$) of Togo in 2002?
Provide a short and direct response. 9.24e+07. What is the difference between the Grants(current US$) in Nepal in 2001 and the Grants(current US$) in Samoa in 2002?
Your answer should be compact. 9.86e+07. What is the difference between the Grants(current US$) in Nepal in 2001 and the Grants(current US$) in Togo in 2002?
Give a very brief answer. 9.26e+07. What is the difference between the Grants(current US$) in Samoa in 2001 and the Grants(current US$) in Togo in 2002?
Keep it short and to the point. -9.37e+06. What is the average Grants(current US$) in Mexico per year?
Keep it short and to the point. 1.21e+08. What is the average Grants(current US$) of Nepal per year?
Your answer should be compact. 1.26e+08. What is the average Grants(current US$) of Samoa per year?
Give a very brief answer. 1.90e+07. What is the average Grants(current US$) of Togo per year?
Offer a terse response. 2.66e+07. In the year 1995, what is the difference between the Grants(current US$) of Mexico and Grants(current US$) of Nepal?
Provide a succinct answer. -1.69e+07. In the year 1995, what is the difference between the Grants(current US$) of Mexico and Grants(current US$) of Samoa?
Offer a very short reply. 1.04e+08. In the year 1995, what is the difference between the Grants(current US$) of Mexico and Grants(current US$) of Togo?
Your answer should be compact. 9.01e+07. In the year 1995, what is the difference between the Grants(current US$) in Nepal and Grants(current US$) in Samoa?
Keep it short and to the point. 1.21e+08. In the year 1995, what is the difference between the Grants(current US$) of Nepal and Grants(current US$) of Togo?
Ensure brevity in your answer.  1.07e+08. In the year 1995, what is the difference between the Grants(current US$) of Samoa and Grants(current US$) of Togo?
Make the answer very short. -1.43e+07. In the year 1996, what is the difference between the Grants(current US$) in Mexico and Grants(current US$) in Nepal?
Ensure brevity in your answer.  -8.91e+06. In the year 1996, what is the difference between the Grants(current US$) in Mexico and Grants(current US$) in Samoa?
Provide a succinct answer. 1.10e+08. In the year 1996, what is the difference between the Grants(current US$) of Mexico and Grants(current US$) of Togo?
Offer a very short reply. 1.02e+08. In the year 1996, what is the difference between the Grants(current US$) of Nepal and Grants(current US$) of Samoa?
Make the answer very short. 1.19e+08. In the year 1996, what is the difference between the Grants(current US$) in Nepal and Grants(current US$) in Togo?
Ensure brevity in your answer.  1.11e+08. In the year 1996, what is the difference between the Grants(current US$) of Samoa and Grants(current US$) of Togo?
Provide a succinct answer. -7.53e+06. In the year 1997, what is the difference between the Grants(current US$) in Mexico and Grants(current US$) in Nepal?
Ensure brevity in your answer.  -3.13e+07. In the year 1997, what is the difference between the Grants(current US$) in Mexico and Grants(current US$) in Samoa?
Give a very brief answer. 8.01e+07. In the year 1997, what is the difference between the Grants(current US$) in Mexico and Grants(current US$) in Togo?
Your answer should be compact. 7.45e+07. In the year 1997, what is the difference between the Grants(current US$) in Nepal and Grants(current US$) in Samoa?
Keep it short and to the point. 1.11e+08. In the year 1997, what is the difference between the Grants(current US$) of Nepal and Grants(current US$) of Togo?
Make the answer very short. 1.06e+08. In the year 1997, what is the difference between the Grants(current US$) in Samoa and Grants(current US$) in Togo?
Make the answer very short. -5.66e+06. In the year 1998, what is the difference between the Grants(current US$) in Mexico and Grants(current US$) in Nepal?
Give a very brief answer. -2.75e+07. In the year 1998, what is the difference between the Grants(current US$) in Mexico and Grants(current US$) in Samoa?
Offer a very short reply. 9.04e+07. In the year 1998, what is the difference between the Grants(current US$) in Mexico and Grants(current US$) in Togo?
Provide a short and direct response. 8.27e+07. In the year 1998, what is the difference between the Grants(current US$) of Nepal and Grants(current US$) of Samoa?
Give a very brief answer. 1.18e+08. In the year 1998, what is the difference between the Grants(current US$) of Nepal and Grants(current US$) of Togo?
Ensure brevity in your answer.  1.10e+08. In the year 1998, what is the difference between the Grants(current US$) of Samoa and Grants(current US$) of Togo?
Your answer should be compact. -7.74e+06. In the year 1999, what is the difference between the Grants(current US$) in Mexico and Grants(current US$) in Nepal?
Give a very brief answer. -1.97e+06. In the year 1999, what is the difference between the Grants(current US$) of Mexico and Grants(current US$) of Samoa?
Your answer should be very brief. 8.48e+07. In the year 1999, what is the difference between the Grants(current US$) of Mexico and Grants(current US$) of Togo?
Make the answer very short. 7.71e+07. In the year 1999, what is the difference between the Grants(current US$) of Nepal and Grants(current US$) of Samoa?
Your response must be concise. 8.68e+07. In the year 1999, what is the difference between the Grants(current US$) of Nepal and Grants(current US$) of Togo?
Ensure brevity in your answer.  7.91e+07. In the year 1999, what is the difference between the Grants(current US$) in Samoa and Grants(current US$) in Togo?
Ensure brevity in your answer.  -7.64e+06. In the year 2000, what is the difference between the Grants(current US$) in Mexico and Grants(current US$) in Nepal?
Your answer should be very brief. 3.13e+06. In the year 2000, what is the difference between the Grants(current US$) of Mexico and Grants(current US$) of Samoa?
Give a very brief answer. 9.14e+07. In the year 2000, what is the difference between the Grants(current US$) of Mexico and Grants(current US$) of Togo?
Offer a terse response. 8.60e+07. In the year 2000, what is the difference between the Grants(current US$) of Nepal and Grants(current US$) of Samoa?
Ensure brevity in your answer.  8.83e+07. In the year 2000, what is the difference between the Grants(current US$) in Nepal and Grants(current US$) in Togo?
Your answer should be compact. 8.29e+07. In the year 2000, what is the difference between the Grants(current US$) in Samoa and Grants(current US$) in Togo?
Give a very brief answer. -5.41e+06. In the year 2001, what is the difference between the Grants(current US$) in Mexico and Grants(current US$) in Samoa?
Provide a succinct answer. 1.02e+08. In the year 2001, what is the difference between the Grants(current US$) of Mexico and Grants(current US$) of Togo?
Provide a short and direct response. 9.54e+07. In the year 2001, what is the difference between the Grants(current US$) of Nepal and Grants(current US$) of Samoa?
Your answer should be very brief. 1.02e+08. In the year 2001, what is the difference between the Grants(current US$) of Nepal and Grants(current US$) of Togo?
Your answer should be compact. 9.55e+07. In the year 2001, what is the difference between the Grants(current US$) of Samoa and Grants(current US$) of Togo?
Ensure brevity in your answer.  -6.46e+06. In the year 2002, what is the difference between the Grants(current US$) in Mexico and Grants(current US$) in Nepal?
Make the answer very short. 4.86e+07. In the year 2002, what is the difference between the Grants(current US$) in Mexico and Grants(current US$) in Samoa?
Provide a short and direct response. 1.56e+08. In the year 2002, what is the difference between the Grants(current US$) of Mexico and Grants(current US$) of Togo?
Offer a terse response. 1.50e+08. In the year 2002, what is the difference between the Grants(current US$) of Nepal and Grants(current US$) of Samoa?
Make the answer very short. 1.07e+08. In the year 2002, what is the difference between the Grants(current US$) of Nepal and Grants(current US$) of Togo?
Offer a very short reply. 1.01e+08. In the year 2002, what is the difference between the Grants(current US$) of Samoa and Grants(current US$) of Togo?
Make the answer very short. -6.06e+06. What is the ratio of the Grants(current US$) in Mexico in 1995 to that in 1996?
Offer a terse response. 0.93. What is the ratio of the Grants(current US$) in Nepal in 1995 to that in 1996?
Keep it short and to the point. 0.99. What is the ratio of the Grants(current US$) of Samoa in 1995 to that in 1996?
Keep it short and to the point. 0.83. What is the ratio of the Grants(current US$) of Togo in 1995 to that in 1996?
Give a very brief answer. 1.12. What is the ratio of the Grants(current US$) of Mexico in 1995 to that in 1997?
Offer a very short reply. 1.2. What is the ratio of the Grants(current US$) in Nepal in 1995 to that in 1997?
Provide a short and direct response. 1.04. What is the ratio of the Grants(current US$) in Samoa in 1995 to that in 1997?
Keep it short and to the point. 0.8. What is the ratio of the Grants(current US$) of Togo in 1995 to that in 1997?
Ensure brevity in your answer.  1.16. What is the ratio of the Grants(current US$) in Mexico in 1995 to that in 1998?
Your response must be concise. 1.1. What is the ratio of the Grants(current US$) in Nepal in 1995 to that in 1998?
Your answer should be very brief. 1. What is the ratio of the Grants(current US$) in Samoa in 1995 to that in 1998?
Your response must be concise. 0.86. What is the ratio of the Grants(current US$) in Togo in 1995 to that in 1998?
Offer a terse response. 1.14. What is the ratio of the Grants(current US$) in Mexico in 1995 to that in 1999?
Your response must be concise. 1.17. What is the ratio of the Grants(current US$) in Nepal in 1995 to that in 1999?
Give a very brief answer. 1.3. What is the ratio of the Grants(current US$) of Samoa in 1995 to that in 1999?
Provide a short and direct response. 0.88. What is the ratio of the Grants(current US$) of Togo in 1995 to that in 1999?
Ensure brevity in your answer.  1.16. What is the ratio of the Grants(current US$) of Nepal in 1995 to that in 2000?
Your answer should be very brief. 1.3. What is the ratio of the Grants(current US$) of Samoa in 1995 to that in 2000?
Offer a very short reply. 0.95. What is the ratio of the Grants(current US$) of Togo in 1995 to that in 2000?
Your answer should be compact. 1.35. What is the ratio of the Grants(current US$) in Mexico in 1995 to that in 2001?
Your response must be concise. 1.02. What is the ratio of the Grants(current US$) of Nepal in 1995 to that in 2001?
Ensure brevity in your answer.  1.16. What is the ratio of the Grants(current US$) of Samoa in 1995 to that in 2001?
Provide a succinct answer. 0.97. What is the ratio of the Grants(current US$) in Togo in 1995 to that in 2001?
Offer a very short reply. 1.31. What is the ratio of the Grants(current US$) of Mexico in 1995 to that in 2002?
Offer a terse response. 0.69. What is the ratio of the Grants(current US$) of Nepal in 1995 to that in 2002?
Offer a very short reply. 1.08. What is the ratio of the Grants(current US$) in Samoa in 1995 to that in 2002?
Your answer should be very brief. 0.82. What is the ratio of the Grants(current US$) of Togo in 1995 to that in 2002?
Your answer should be compact. 1.17. What is the ratio of the Grants(current US$) in Mexico in 1996 to that in 1997?
Keep it short and to the point. 1.28. What is the ratio of the Grants(current US$) in Nepal in 1996 to that in 1997?
Provide a short and direct response. 1.05. What is the ratio of the Grants(current US$) of Samoa in 1996 to that in 1997?
Provide a succinct answer. 0.96. What is the ratio of the Grants(current US$) of Togo in 1996 to that in 1997?
Your answer should be very brief. 1.04. What is the ratio of the Grants(current US$) in Mexico in 1996 to that in 1998?
Keep it short and to the point. 1.18. What is the ratio of the Grants(current US$) of Nepal in 1996 to that in 1998?
Make the answer very short. 1.01. What is the ratio of the Grants(current US$) of Samoa in 1996 to that in 1998?
Give a very brief answer. 1.03. What is the ratio of the Grants(current US$) in Togo in 1996 to that in 1998?
Ensure brevity in your answer.  1.02. What is the ratio of the Grants(current US$) in Mexico in 1996 to that in 1999?
Keep it short and to the point. 1.25. What is the ratio of the Grants(current US$) in Nepal in 1996 to that in 1999?
Give a very brief answer. 1.31. What is the ratio of the Grants(current US$) of Samoa in 1996 to that in 1999?
Give a very brief answer. 1.06. What is the ratio of the Grants(current US$) in Togo in 1996 to that in 1999?
Your answer should be compact. 1.04. What is the ratio of the Grants(current US$) in Mexico in 1996 to that in 2000?
Your response must be concise. 1.19. What is the ratio of the Grants(current US$) of Nepal in 1996 to that in 2000?
Provide a succinct answer. 1.31. What is the ratio of the Grants(current US$) in Samoa in 1996 to that in 2000?
Provide a short and direct response. 1.15. What is the ratio of the Grants(current US$) in Togo in 1996 to that in 2000?
Provide a short and direct response. 1.2. What is the ratio of the Grants(current US$) in Mexico in 1996 to that in 2001?
Provide a short and direct response. 1.09. What is the ratio of the Grants(current US$) of Nepal in 1996 to that in 2001?
Make the answer very short. 1.17. What is the ratio of the Grants(current US$) of Samoa in 1996 to that in 2001?
Provide a short and direct response. 1.17. What is the ratio of the Grants(current US$) of Togo in 1996 to that in 2001?
Ensure brevity in your answer.  1.17. What is the ratio of the Grants(current US$) of Mexico in 1996 to that in 2002?
Provide a short and direct response. 0.74. What is the ratio of the Grants(current US$) in Nepal in 1996 to that in 2002?
Provide a short and direct response. 1.09. What is the ratio of the Grants(current US$) in Samoa in 1996 to that in 2002?
Give a very brief answer. 0.98. What is the ratio of the Grants(current US$) in Togo in 1996 to that in 2002?
Ensure brevity in your answer.  1.04. What is the ratio of the Grants(current US$) of Mexico in 1997 to that in 1998?
Keep it short and to the point. 0.92. What is the ratio of the Grants(current US$) in Nepal in 1997 to that in 1998?
Keep it short and to the point. 0.96. What is the ratio of the Grants(current US$) of Samoa in 1997 to that in 1998?
Your answer should be very brief. 1.08. What is the ratio of the Grants(current US$) of Togo in 1997 to that in 1998?
Make the answer very short. 0.98. What is the ratio of the Grants(current US$) in Mexico in 1997 to that in 1999?
Your answer should be very brief. 0.97. What is the ratio of the Grants(current US$) of Nepal in 1997 to that in 1999?
Offer a terse response. 1.25. What is the ratio of the Grants(current US$) of Samoa in 1997 to that in 1999?
Your answer should be compact. 1.11. What is the ratio of the Grants(current US$) in Mexico in 1997 to that in 2000?
Offer a terse response. 0.93. What is the ratio of the Grants(current US$) in Nepal in 1997 to that in 2000?
Give a very brief answer. 1.25. What is the ratio of the Grants(current US$) of Samoa in 1997 to that in 2000?
Offer a very short reply. 1.2. What is the ratio of the Grants(current US$) in Togo in 1997 to that in 2000?
Offer a very short reply. 1.16. What is the ratio of the Grants(current US$) in Mexico in 1997 to that in 2001?
Offer a very short reply. 0.85. What is the ratio of the Grants(current US$) of Nepal in 1997 to that in 2001?
Your answer should be very brief. 1.11. What is the ratio of the Grants(current US$) in Samoa in 1997 to that in 2001?
Your response must be concise. 1.22. What is the ratio of the Grants(current US$) of Togo in 1997 to that in 2001?
Ensure brevity in your answer.  1.13. What is the ratio of the Grants(current US$) of Mexico in 1997 to that in 2002?
Provide a succinct answer. 0.57. What is the ratio of the Grants(current US$) in Nepal in 1997 to that in 2002?
Give a very brief answer. 1.04. What is the ratio of the Grants(current US$) in Samoa in 1997 to that in 2002?
Offer a very short reply. 1.03. What is the ratio of the Grants(current US$) of Togo in 1997 to that in 2002?
Offer a very short reply. 1. What is the ratio of the Grants(current US$) of Mexico in 1998 to that in 1999?
Keep it short and to the point. 1.06. What is the ratio of the Grants(current US$) in Nepal in 1998 to that in 1999?
Offer a very short reply. 1.3. What is the ratio of the Grants(current US$) in Samoa in 1998 to that in 1999?
Your response must be concise. 1.03. What is the ratio of the Grants(current US$) of Togo in 1998 to that in 1999?
Ensure brevity in your answer.  1.02. What is the ratio of the Grants(current US$) of Mexico in 1998 to that in 2000?
Your response must be concise. 1.01. What is the ratio of the Grants(current US$) of Nepal in 1998 to that in 2000?
Offer a terse response. 1.3. What is the ratio of the Grants(current US$) of Samoa in 1998 to that in 2000?
Offer a terse response. 1.11. What is the ratio of the Grants(current US$) of Togo in 1998 to that in 2000?
Make the answer very short. 1.18. What is the ratio of the Grants(current US$) in Mexico in 1998 to that in 2001?
Your answer should be compact. 0.92. What is the ratio of the Grants(current US$) of Nepal in 1998 to that in 2001?
Provide a short and direct response. 1.15. What is the ratio of the Grants(current US$) in Samoa in 1998 to that in 2001?
Give a very brief answer. 1.13. What is the ratio of the Grants(current US$) of Togo in 1998 to that in 2001?
Offer a very short reply. 1.15. What is the ratio of the Grants(current US$) of Mexico in 1998 to that in 2002?
Give a very brief answer. 0.62. What is the ratio of the Grants(current US$) in Nepal in 1998 to that in 2002?
Make the answer very short. 1.08. What is the ratio of the Grants(current US$) of Samoa in 1998 to that in 2002?
Your response must be concise. 0.95. What is the ratio of the Grants(current US$) of Togo in 1998 to that in 2002?
Your answer should be very brief. 1.02. What is the ratio of the Grants(current US$) in Mexico in 1999 to that in 2000?
Your answer should be compact. 0.95. What is the ratio of the Grants(current US$) in Samoa in 1999 to that in 2000?
Your answer should be compact. 1.08. What is the ratio of the Grants(current US$) of Togo in 1999 to that in 2000?
Provide a short and direct response. 1.16. What is the ratio of the Grants(current US$) in Mexico in 1999 to that in 2001?
Offer a terse response. 0.87. What is the ratio of the Grants(current US$) of Nepal in 1999 to that in 2001?
Your response must be concise. 0.89. What is the ratio of the Grants(current US$) in Samoa in 1999 to that in 2001?
Offer a terse response. 1.1. What is the ratio of the Grants(current US$) of Togo in 1999 to that in 2001?
Provide a succinct answer. 1.13. What is the ratio of the Grants(current US$) of Mexico in 1999 to that in 2002?
Your answer should be very brief. 0.59. What is the ratio of the Grants(current US$) of Nepal in 1999 to that in 2002?
Make the answer very short. 0.83. What is the ratio of the Grants(current US$) in Samoa in 1999 to that in 2002?
Provide a short and direct response. 0.93. What is the ratio of the Grants(current US$) of Mexico in 2000 to that in 2001?
Offer a terse response. 0.92. What is the ratio of the Grants(current US$) in Nepal in 2000 to that in 2001?
Your answer should be very brief. 0.89. What is the ratio of the Grants(current US$) of Togo in 2000 to that in 2001?
Provide a succinct answer. 0.97. What is the ratio of the Grants(current US$) in Mexico in 2000 to that in 2002?
Make the answer very short. 0.62. What is the ratio of the Grants(current US$) of Nepal in 2000 to that in 2002?
Give a very brief answer. 0.83. What is the ratio of the Grants(current US$) in Samoa in 2000 to that in 2002?
Provide a short and direct response. 0.86. What is the ratio of the Grants(current US$) in Togo in 2000 to that in 2002?
Offer a very short reply. 0.87. What is the ratio of the Grants(current US$) in Mexico in 2001 to that in 2002?
Provide a succinct answer. 0.68. What is the ratio of the Grants(current US$) of Nepal in 2001 to that in 2002?
Offer a very short reply. 0.93. What is the ratio of the Grants(current US$) in Samoa in 2001 to that in 2002?
Keep it short and to the point. 0.84. What is the ratio of the Grants(current US$) of Togo in 2001 to that in 2002?
Make the answer very short. 0.89. What is the difference between the highest and the second highest Grants(current US$) of Mexico?
Provide a succinct answer. 4.64e+07. What is the difference between the highest and the second highest Grants(current US$) in Nepal?
Provide a succinct answer. 8.40e+05. What is the difference between the highest and the second highest Grants(current US$) in Samoa?
Provide a succinct answer. 5.30e+05. What is the difference between the highest and the second highest Grants(current US$) in Togo?
Keep it short and to the point. 3.35e+06. What is the difference between the highest and the lowest Grants(current US$) in Mexico?
Make the answer very short. 7.51e+07. What is the difference between the highest and the lowest Grants(current US$) in Nepal?
Provide a succinct answer. 3.31e+07. What is the difference between the highest and the lowest Grants(current US$) of Samoa?
Offer a very short reply. 4.32e+06. What is the difference between the highest and the lowest Grants(current US$) of Togo?
Provide a short and direct response. 8.04e+06. 